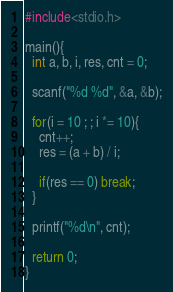<code> <loc_0><loc_0><loc_500><loc_500><_C_>#include<stdio.h>

main(){
  int a, b, i, res, cnt = 0;

  scanf("%d %d", &a, &b);

  for(i = 10 ; ; i *= 10){
    cnt++;
    res = (a + b) / i;

    if(res == 0) break;
  }

  printf("%d\n", cnt);

  return 0;
}</code> 